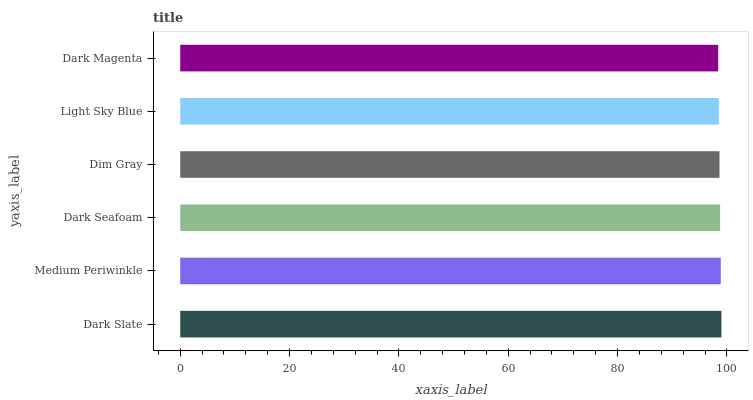Is Dark Magenta the minimum?
Answer yes or no. Yes. Is Dark Slate the maximum?
Answer yes or no. Yes. Is Medium Periwinkle the minimum?
Answer yes or no. No. Is Medium Periwinkle the maximum?
Answer yes or no. No. Is Dark Slate greater than Medium Periwinkle?
Answer yes or no. Yes. Is Medium Periwinkle less than Dark Slate?
Answer yes or no. Yes. Is Medium Periwinkle greater than Dark Slate?
Answer yes or no. No. Is Dark Slate less than Medium Periwinkle?
Answer yes or no. No. Is Dark Seafoam the high median?
Answer yes or no. Yes. Is Dim Gray the low median?
Answer yes or no. Yes. Is Light Sky Blue the high median?
Answer yes or no. No. Is Medium Periwinkle the low median?
Answer yes or no. No. 